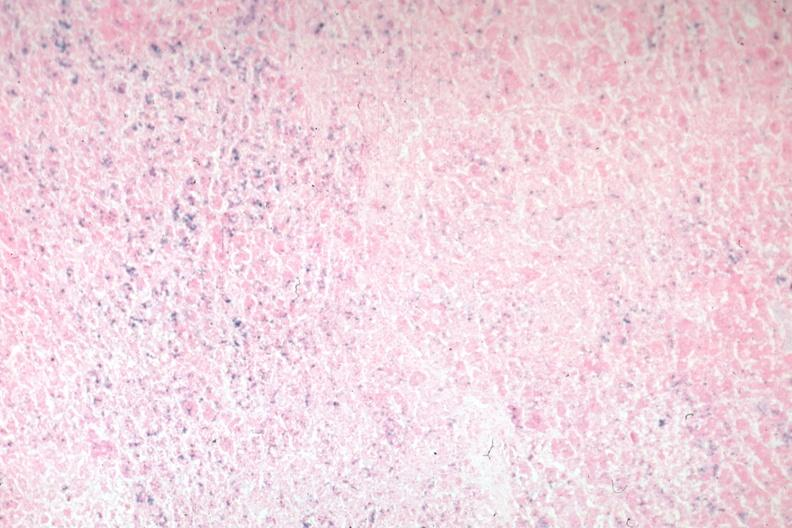s pituitary present?
Answer the question using a single word or phrase. Yes 